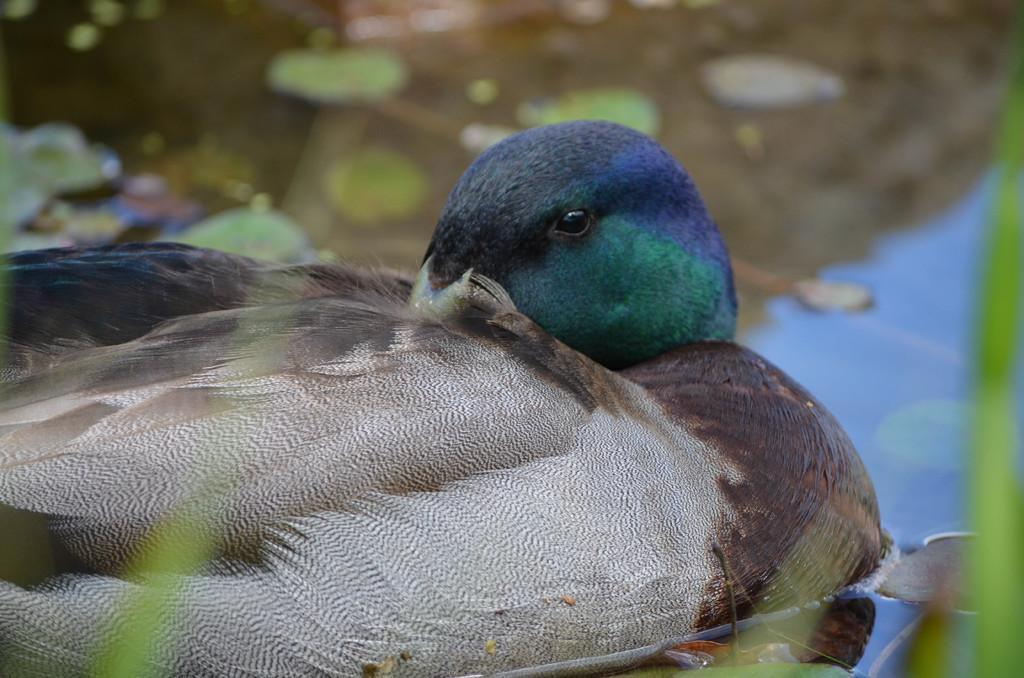Can you describe this image briefly? In this picture we can see a bird and the bird is called as a "Mallard". Behind the bird there is water and blurred background. 